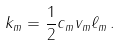<formula> <loc_0><loc_0><loc_500><loc_500>k _ { m } = \frac { 1 } { 2 } c _ { m } v _ { m } \ell _ { m } \, .</formula> 